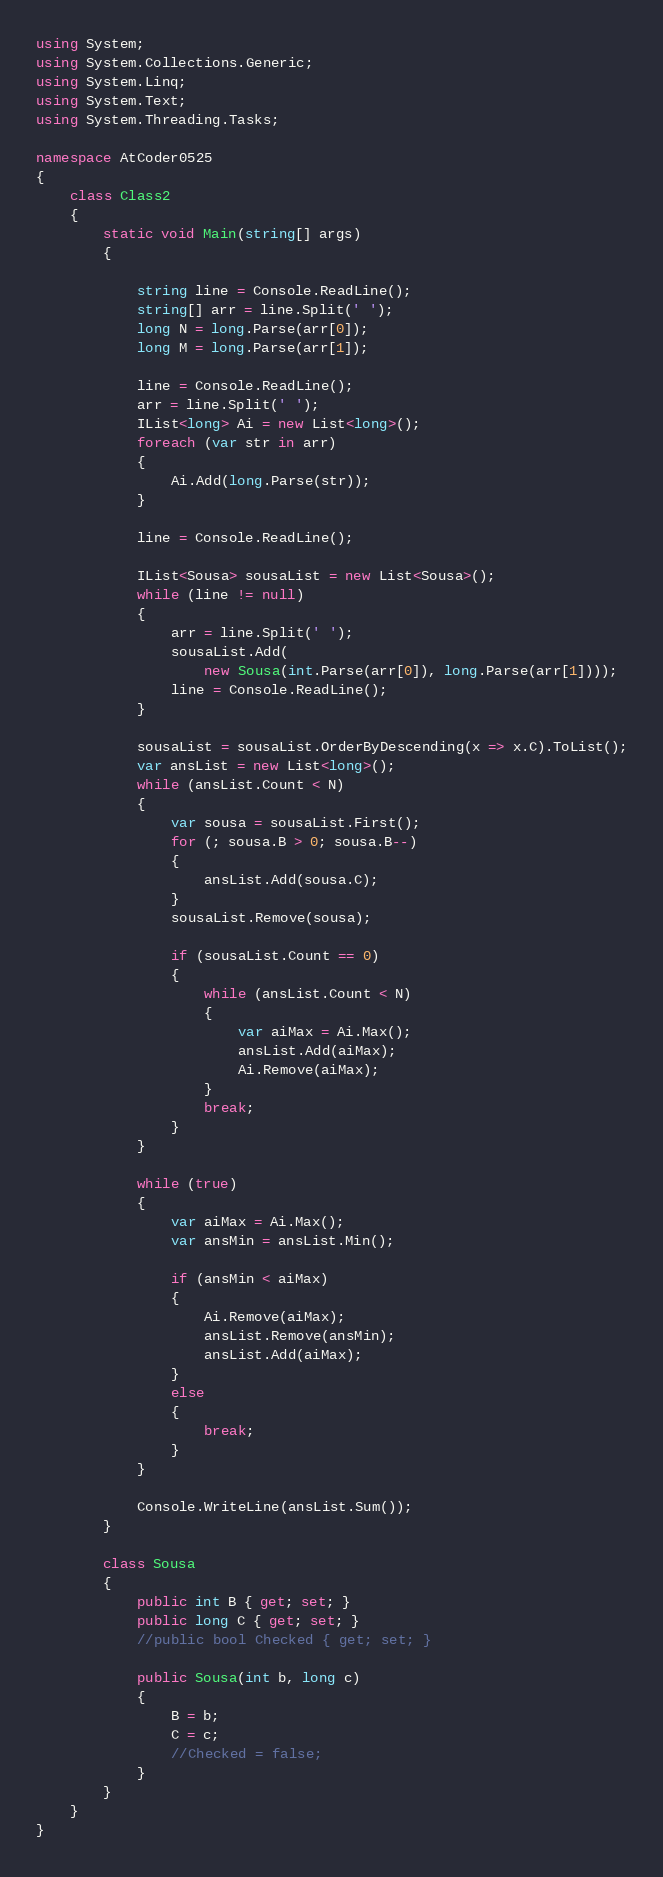Convert code to text. <code><loc_0><loc_0><loc_500><loc_500><_C#_>using System;
using System.Collections.Generic;
using System.Linq;
using System.Text;
using System.Threading.Tasks;

namespace AtCoder0525
{
    class Class2
    {
        static void Main(string[] args)
        {

            string line = Console.ReadLine();
            string[] arr = line.Split(' ');
            long N = long.Parse(arr[0]);
            long M = long.Parse(arr[1]);

            line = Console.ReadLine();
            arr = line.Split(' ');
            IList<long> Ai = new List<long>();
            foreach (var str in arr)
            {
                Ai.Add(long.Parse(str));
            }
            
            line = Console.ReadLine();

            IList<Sousa> sousaList = new List<Sousa>();
            while (line != null)
            {
                arr = line.Split(' ');
                sousaList.Add(
                    new Sousa(int.Parse(arr[0]), long.Parse(arr[1])));
                line = Console.ReadLine();
            }

            sousaList = sousaList.OrderByDescending(x => x.C).ToList();
            var ansList = new List<long>();
            while (ansList.Count < N)
            {
                var sousa = sousaList.First();
                for (; sousa.B > 0; sousa.B--)
                {
                    ansList.Add(sousa.C);
                }
                sousaList.Remove(sousa);

                if (sousaList.Count == 0)
                {
                    while (ansList.Count < N)
                    {
                        var aiMax = Ai.Max();
                        ansList.Add(aiMax);
                        Ai.Remove(aiMax);
                    }
                    break;
                }
            }

            while (true)
            {
                var aiMax = Ai.Max();
                var ansMin = ansList.Min();

                if (ansMin < aiMax)
                {
                    Ai.Remove(aiMax);
                    ansList.Remove(ansMin);
                    ansList.Add(aiMax);
                }
                else
                {
                    break;
                }
            }

            Console.WriteLine(ansList.Sum());
        }

        class Sousa
        {
            public int B { get; set; }
            public long C { get; set; }
            //public bool Checked { get; set; }

            public Sousa(int b, long c)
            {
                B = b;
                C = c;
                //Checked = false;
            }
        }
    }
}
</code> 